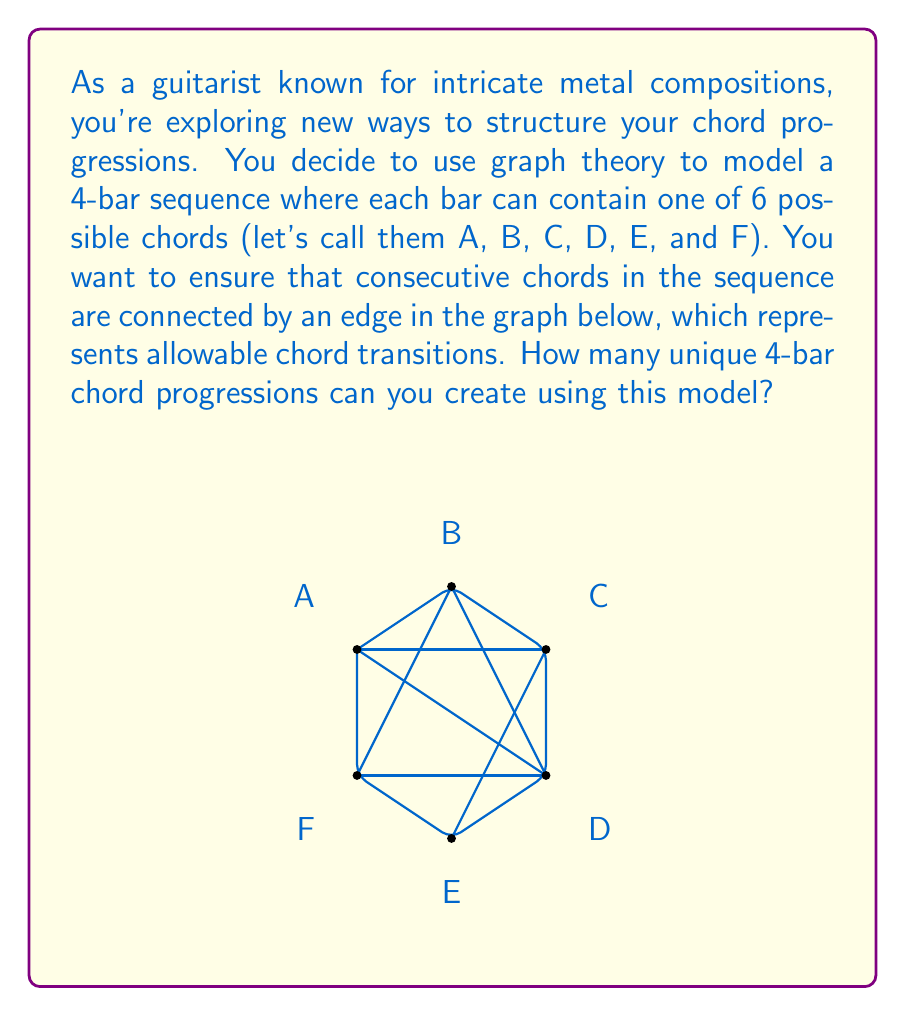Can you answer this question? To solve this problem, we'll use the concept of adjacency matrices and matrix multiplication from graph theory. Here's a step-by-step approach:

1) First, we need to create the adjacency matrix for the given graph. The adjacency matrix $A$ will be a 6x6 matrix where $A_{ij} = 1$ if there's an edge from chord i to chord j, and 0 otherwise.

$$A = \begin{bmatrix}
0 & 1 & 1 & 1 & 0 & 1 \\
1 & 0 & 1 & 1 & 0 & 1 \\
1 & 1 & 0 & 1 & 1 & 0 \\
1 & 1 & 1 & 0 & 1 & 1 \\
0 & 0 & 1 & 1 & 0 & 1 \\
1 & 1 & 0 & 1 & 1 & 0
\end{bmatrix}$$

2) In graph theory, $(A^n)_{ij}$ represents the number of walks of length n from vertex i to vertex j. We want to find the total number of walks of length 3 (representing the transitions between the 4 bars) starting from any vertex.

3) To do this, we need to calculate $A^3$. We can do this by multiplying A by itself three times:

$$A^3 = A \times A \times A$$

4) After performing this multiplication (which is computationally intensive and typically done by computer), we get:

$$A^3 = \begin{bmatrix}
20 & 20 & 21 & 25 & 16 & 20 \\
20 & 20 & 21 & 25 & 16 & 20 \\
21 & 21 & 20 & 25 & 17 & 21 \\
25 & 25 & 25 & 29 & 21 & 25 \\
16 & 16 & 17 & 21 & 12 & 16 \\
20 & 20 & 21 & 25 & 16 & 20
\end{bmatrix}$$

5) The sum of all elements in this matrix gives us the total number of walks of length 3 starting from any vertex and ending at any vertex.

6) The sum of all elements in $A^3$ is 1122.

Therefore, there are 1122 unique 4-bar chord progressions possible using this model.
Answer: 1122 unique chord progressions 